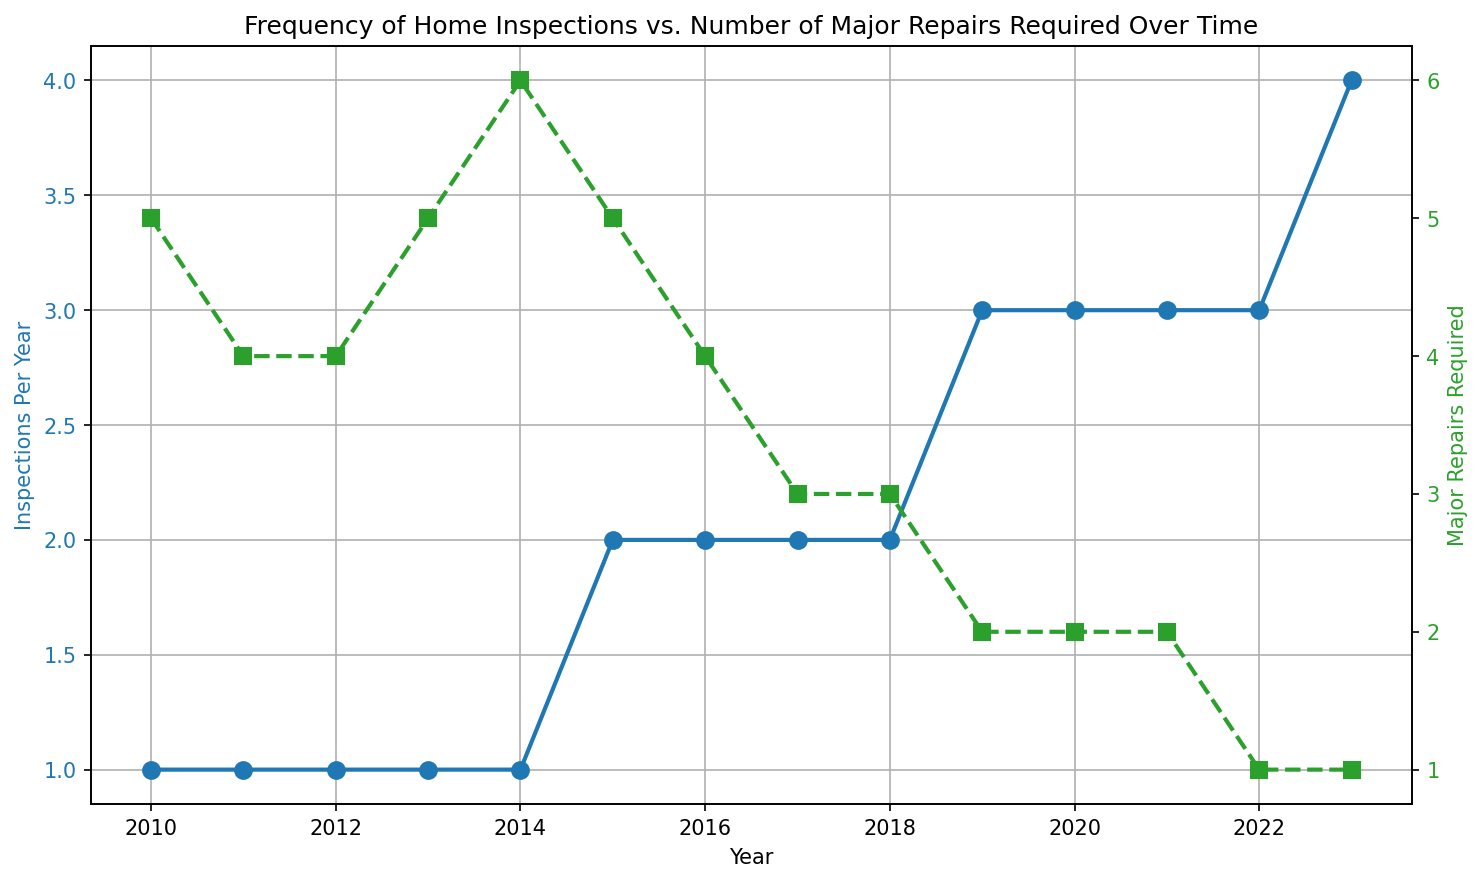What's the trend of Inspections Per Year over the period 2010 to 2023? The trend can be observed by looking at the line representing Inspections Per Year. Starting from 2010, the value gradually increases, with slight changes until 2013, remains relatively stable till 2015, and then increases more steeply from 2016 onwards, reaching its highest point in 2023.
Answer: Increasing Compare the number of Major Repairs Required in the years 2010 and 2023. In the year 2010, the Major Repairs Required is 5, whereas in 2023, it is 1. By comparing these values, we see a decrease from 5 to 1 over this period.
Answer: Decreased What is the maximum number of Inspections Per Year and in which year does it occur? By looking at the peak point of the blue line which represents Inspections Per Year, we see the maximum value is 4, occurring in 2023.
Answer: 4 in 2023 How many times did the Major Repairs Required equal 2 over the period shown? By examining the green line representing Major Repairs Required, we see that it equals 2 in the years 2019, 2020, and 2021, so this happens 3 times in total.
Answer: 3 times What's the average number of Major Repairs Required from 2010 to 2014? We sum the Major Repairs Required for the years 2010 to 2014: 5 + 4 + 4 + 5 + 6 = 24. There are 5 years, so the average is 24 / 5 = 4.8.
Answer: 4.8 Which had more fluctuation over the years: Inspections Per Year or Major Repairs Required? By observing the variation in the plotted lines, we notice that Inspections Per Year shows a general upward trend with minor fluctuations, while Major Repairs Required fluctuates more noticeably, decreasing from year to year with several ups and downs in the early period.
Answer: Major Repairs Required What’s the difference in the number of Major Repairs Required between 2013 and 2017? In 2013, the number of Major Repairs Required is 5, and in 2017 it is 3. The difference is 5 - 3 = 2.
Answer: 2 How did the number of Inspections Per Year change between 2015 and 2017, and how did it correlate with Major Repairs Required in the same period? From 2015 to 2017, the number of Inspections Per Year increased from 2 to 2 (remained the same), while the Major Repairs Required decreased from 5 to 3. Even with the same number of inspections, the major repairs reduced.
Answer: Increased inspections, decreased repairs Describe the color and marker style used for representing Major Repairs Required. The Major Repairs Required line is plotted with a green color and square markers.
Answer: Green with square markers What’s the total number of Inspections Per Year from 2019 to 2023, and how does that compare to the total Major Repairs Required in the same period? Total Inspections Per Year from 2019 to 2023: 3 + 3 + 3 + 3 + 4 = 16. Total Major Repairs Required from 2019 to 2023: 2 + 2 + 2 + 1 + 1 = 8. Comparison shows that total inspections are 16, and total repairs are 8 over this period.
Answer: 16 inspections, 8 repairs 